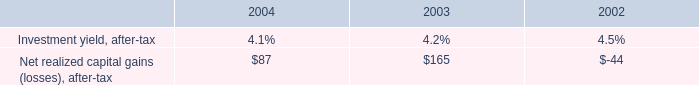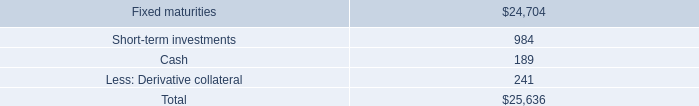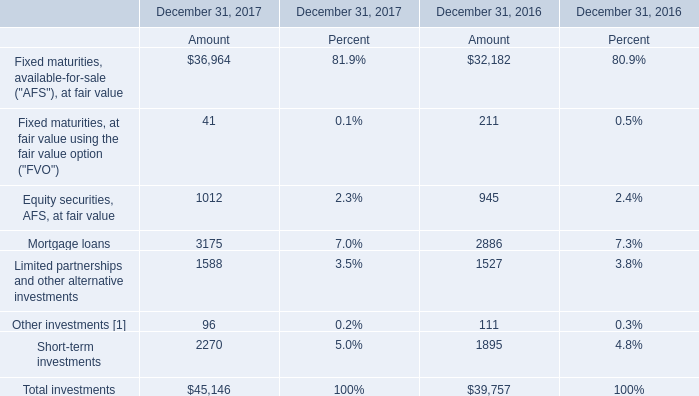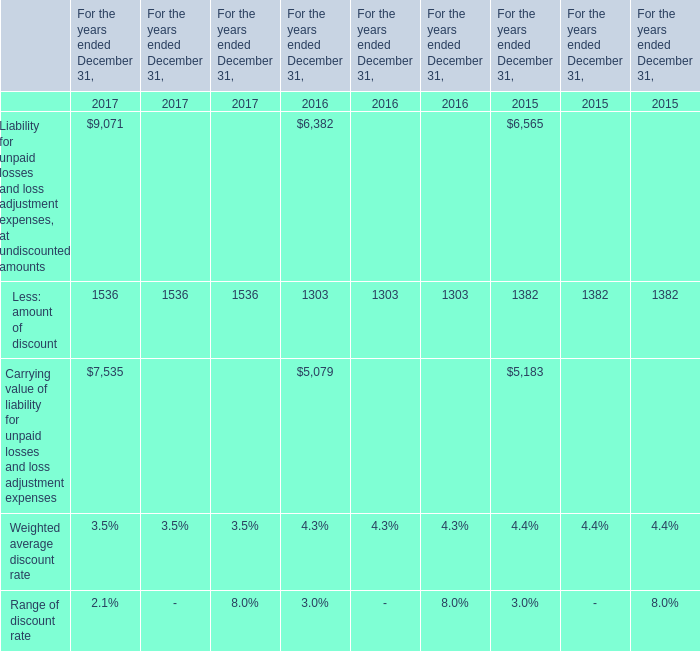what is the total net realized gain for the last three years? 
Computations: ((87 + 165) - 44)
Answer: 208.0. 